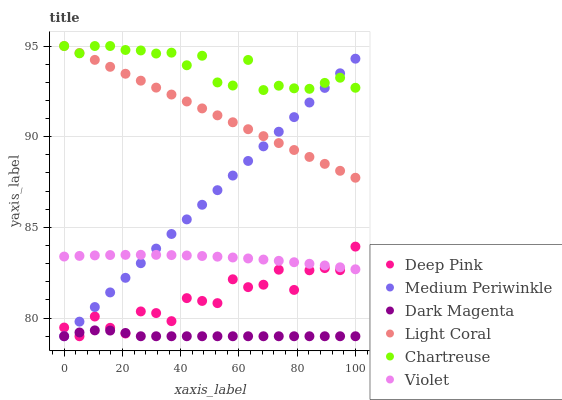Does Dark Magenta have the minimum area under the curve?
Answer yes or no. Yes. Does Chartreuse have the maximum area under the curve?
Answer yes or no. Yes. Does Medium Periwinkle have the minimum area under the curve?
Answer yes or no. No. Does Medium Periwinkle have the maximum area under the curve?
Answer yes or no. No. Is Light Coral the smoothest?
Answer yes or no. Yes. Is Deep Pink the roughest?
Answer yes or no. Yes. Is Dark Magenta the smoothest?
Answer yes or no. No. Is Dark Magenta the roughest?
Answer yes or no. No. Does Deep Pink have the lowest value?
Answer yes or no. Yes. Does Light Coral have the lowest value?
Answer yes or no. No. Does Chartreuse have the highest value?
Answer yes or no. Yes. Does Medium Periwinkle have the highest value?
Answer yes or no. No. Is Dark Magenta less than Light Coral?
Answer yes or no. Yes. Is Violet greater than Dark Magenta?
Answer yes or no. Yes. Does Deep Pink intersect Violet?
Answer yes or no. Yes. Is Deep Pink less than Violet?
Answer yes or no. No. Is Deep Pink greater than Violet?
Answer yes or no. No. Does Dark Magenta intersect Light Coral?
Answer yes or no. No. 